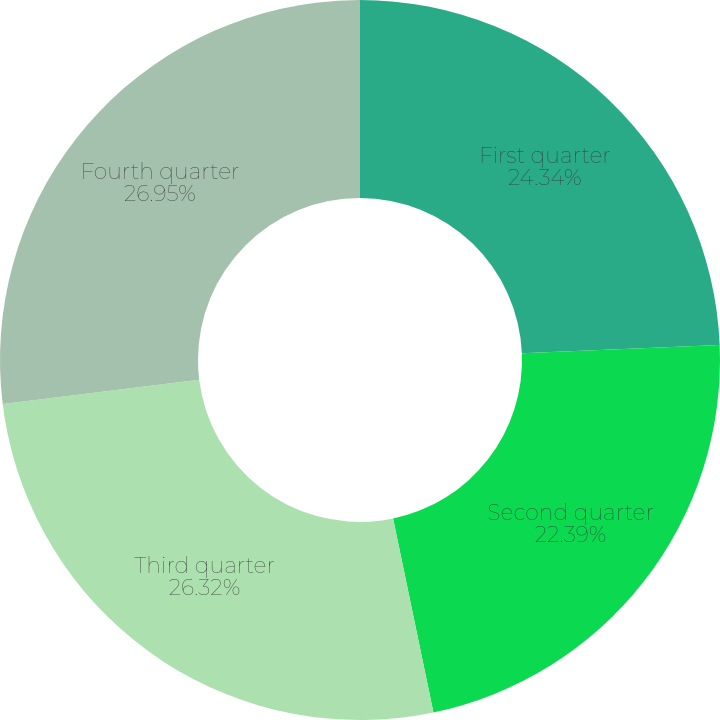Convert chart. <chart><loc_0><loc_0><loc_500><loc_500><pie_chart><fcel>First quarter<fcel>Second quarter<fcel>Third quarter<fcel>Fourth quarter<nl><fcel>24.34%<fcel>22.39%<fcel>26.32%<fcel>26.95%<nl></chart> 